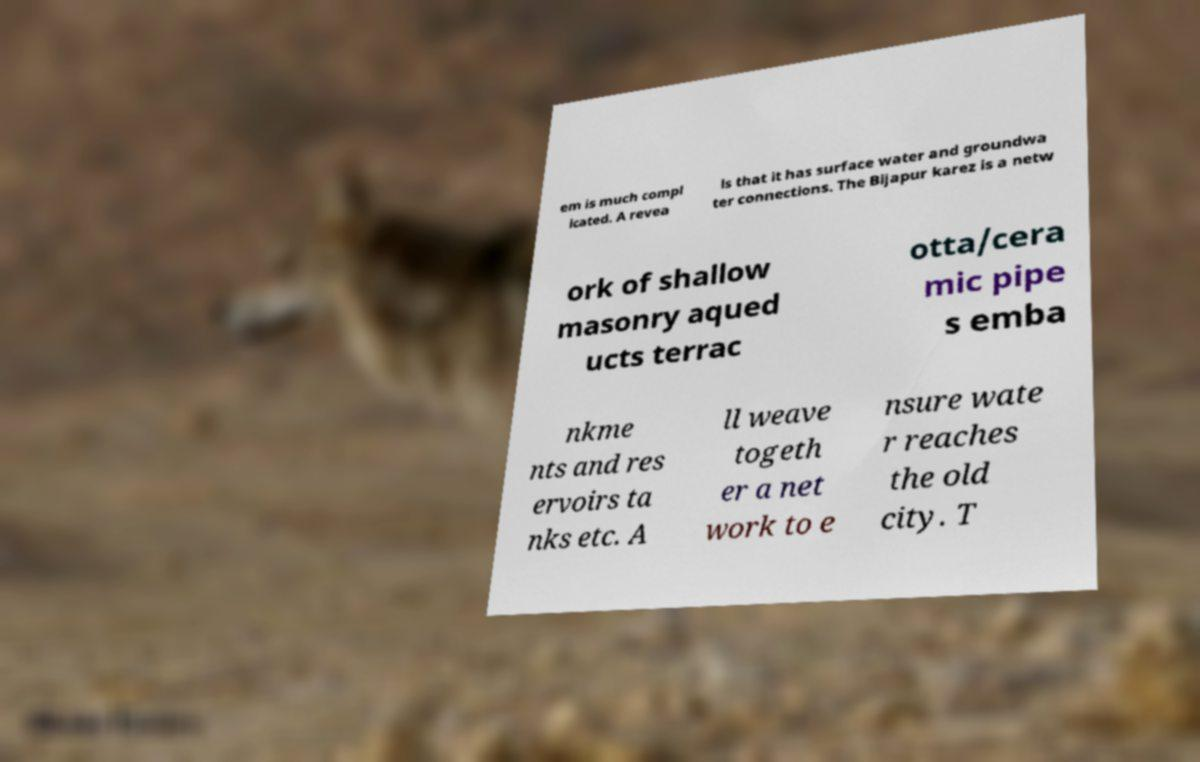There's text embedded in this image that I need extracted. Can you transcribe it verbatim? em is much compl icated. A revea ls that it has surface water and groundwa ter connections. The Bijapur karez is a netw ork of shallow masonry aqued ucts terrac otta/cera mic pipe s emba nkme nts and res ervoirs ta nks etc. A ll weave togeth er a net work to e nsure wate r reaches the old city. T 